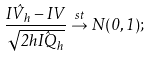<formula> <loc_0><loc_0><loc_500><loc_500>\frac { \hat { I V _ { h } } - I V } { \sqrt { 2 h \hat { I Q } _ { h } } } \stackrel { s t } \rightarrow { N } ( 0 , 1 ) ;</formula> 